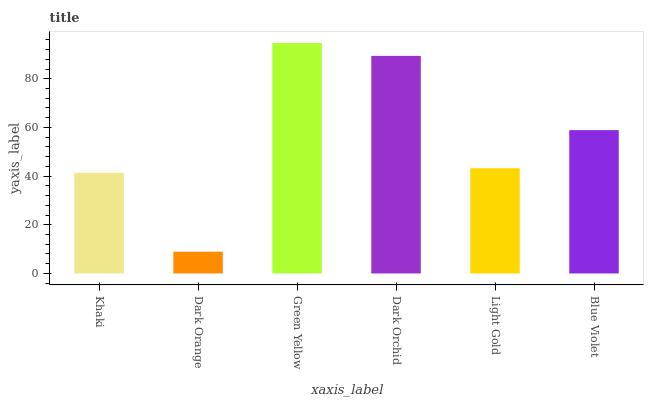Is Dark Orange the minimum?
Answer yes or no. Yes. Is Green Yellow the maximum?
Answer yes or no. Yes. Is Green Yellow the minimum?
Answer yes or no. No. Is Dark Orange the maximum?
Answer yes or no. No. Is Green Yellow greater than Dark Orange?
Answer yes or no. Yes. Is Dark Orange less than Green Yellow?
Answer yes or no. Yes. Is Dark Orange greater than Green Yellow?
Answer yes or no. No. Is Green Yellow less than Dark Orange?
Answer yes or no. No. Is Blue Violet the high median?
Answer yes or no. Yes. Is Light Gold the low median?
Answer yes or no. Yes. Is Green Yellow the high median?
Answer yes or no. No. Is Khaki the low median?
Answer yes or no. No. 